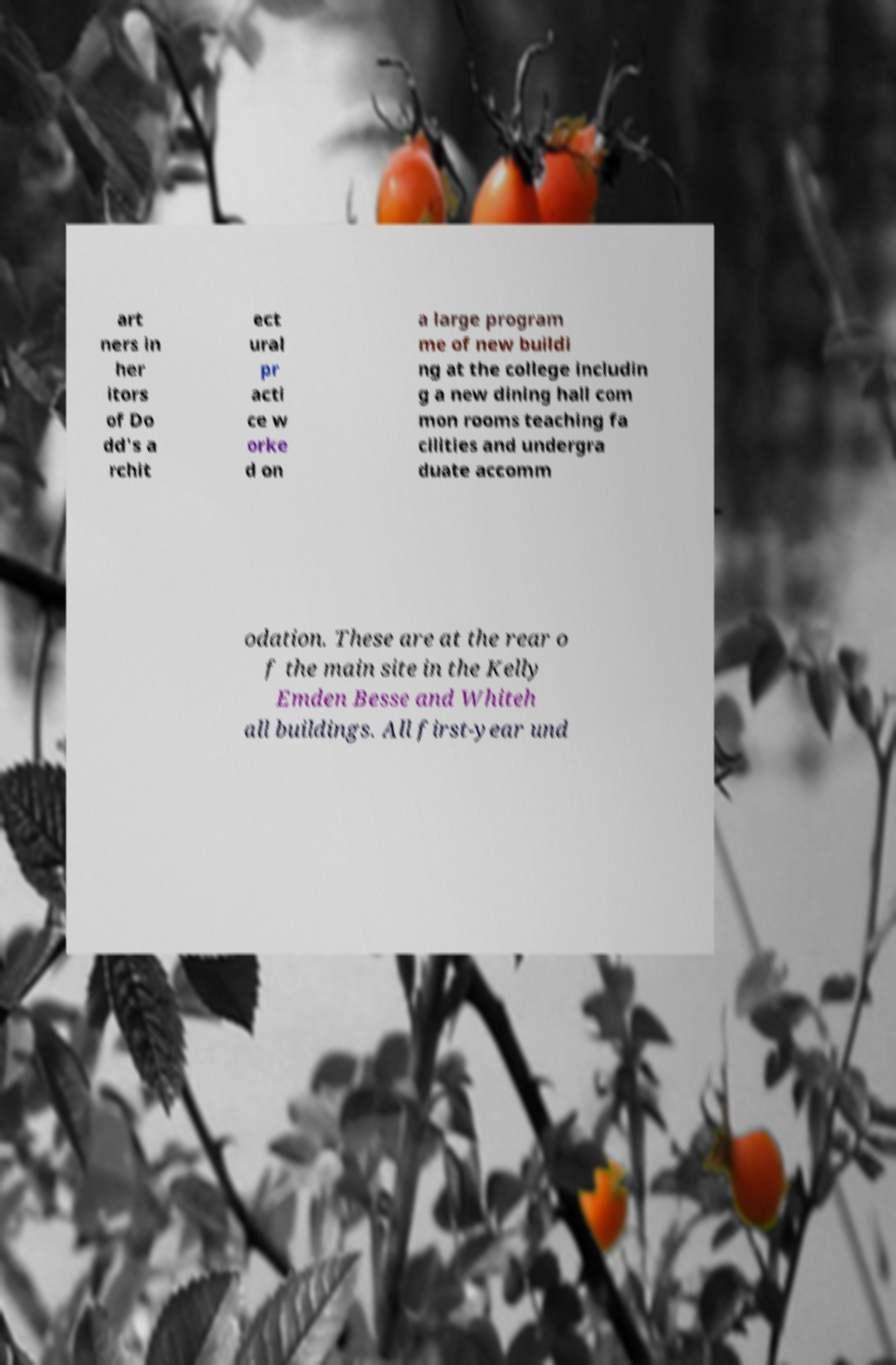Could you extract and type out the text from this image? art ners in her itors of Do dd's a rchit ect ural pr acti ce w orke d on a large program me of new buildi ng at the college includin g a new dining hall com mon rooms teaching fa cilities and undergra duate accomm odation. These are at the rear o f the main site in the Kelly Emden Besse and Whiteh all buildings. All first-year und 